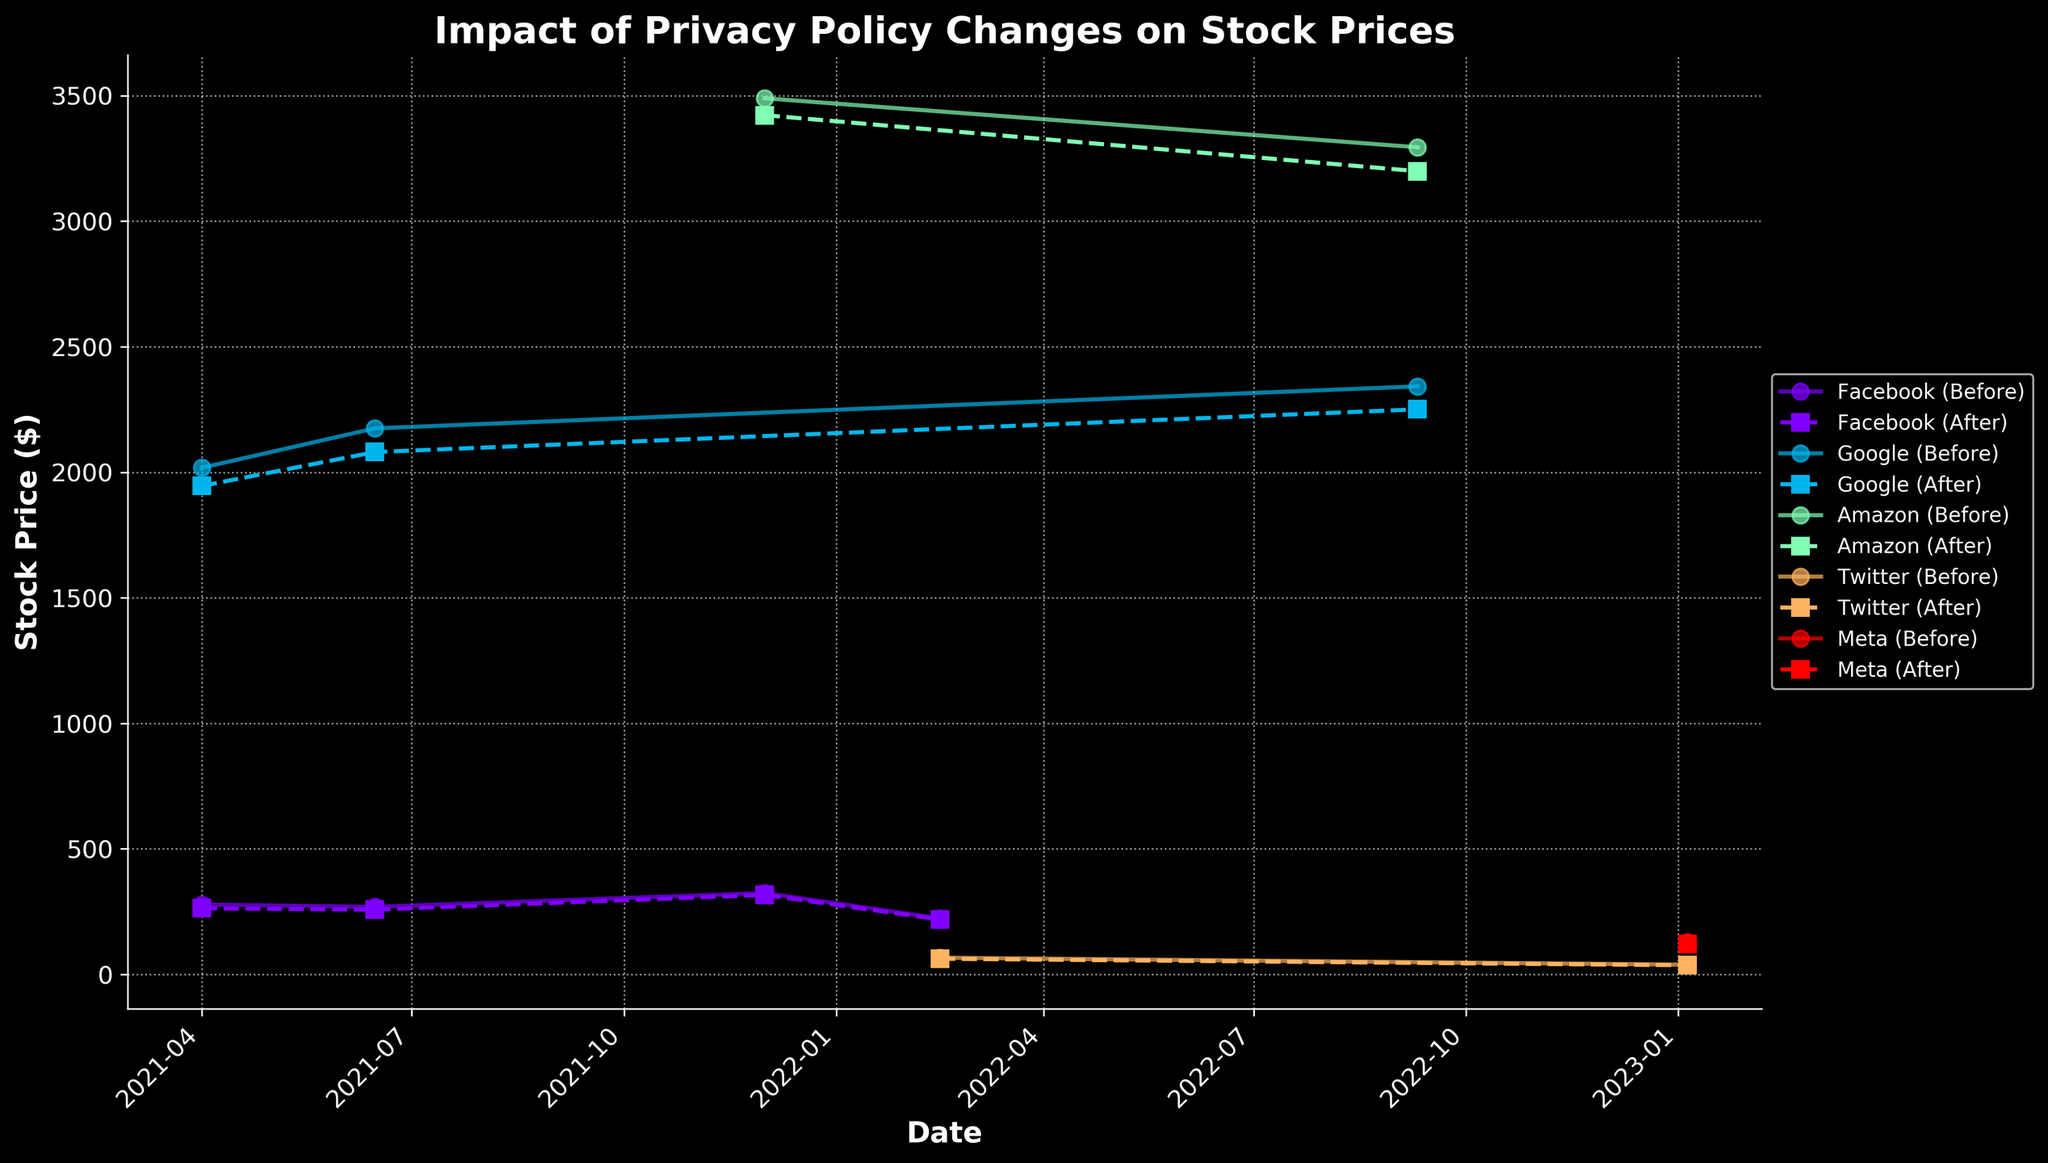What's the main title of the plot? The main title is visible at the top of the plot and gives an overview of what the plot represents.
Answer: Impact of Privacy Policy Changes on Stock Prices What are the companies represented in the plot? The companies are labeled within the plot legend, which lists the unique identifiers used in the data.
Answer: Facebook, Google, Amazon, Twitter, Meta How do the stock prices of Facebook compare before and after the announcement of Apple's iOS 14.5 update on 2021-04-01? Look at the plot markers for Facebook on the specified date. The plot shows different markers for before and after prices.
Answer: Before: 278.62, After: 263.50 What is the difference in Google's stock price before and after the implementation of GDPR in Europe on 2021-06-15? Locate the plot markers for Google on the specified date. Subtract the after price from the before price.
Answer: 94.40 On which date did Amazon's stock price drop after a privacy policy change, and what was the drop in price? Check for the specific dates indicated on the plot where Amazon's stock prices are shown. Calculate the price drop by subtracting the after price from the before price.
Answer: 2022-09-10, 95.26 Which company had the highest stock price before any privacy policy change occurred? Look at the maximum value among the 'Stock Price Before' markers for all companies.
Answer: Amazon During which event did Twitter's stock experience a decline, and what was the percentage decrease in stock price? Identify the events associated with Twitter's stock prices. Calculate the percentage decrease by taking the difference in prices, dividing by the 'before' price, and multiplying by 100.
Answer: Privacy Policy Change - Enhanced Data Protection, 6.255% What was the average stock price of Facebook before any privacy policy changes within the plotted period? Sum all the 'Stock Price Before' values for Facebook and divide by the number of occurrences.
Answer: 274.49 Which company experienced multiple stock price declines due to different privacy policy events, and what were the events? Check the plot for recurrent declines associated with a particular company and note down the events labeled on the plot.
Answer: Facebook, Apple's iOS 14.5 Update Announcement, Implementation of GDPR in Europe, Update to California Consumer Privacy Act (CCPA), Privacy Policy Change - Enhanced Data Protection 